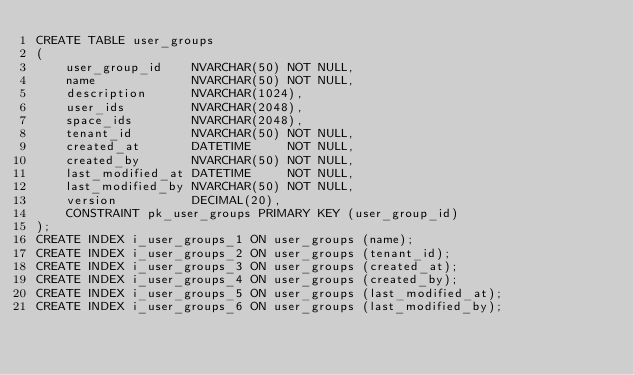<code> <loc_0><loc_0><loc_500><loc_500><_SQL_>CREATE TABLE user_groups
(
    user_group_id    NVARCHAR(50) NOT NULL,
    name             NVARCHAR(50) NOT NULL,
    description      NVARCHAR(1024),
    user_ids         NVARCHAR(2048),
    space_ids        NVARCHAR(2048),
    tenant_id        NVARCHAR(50) NOT NULL,
    created_at       DATETIME     NOT NULL,
    created_by       NVARCHAR(50) NOT NULL,
    last_modified_at DATETIME     NOT NULL,
    last_modified_by NVARCHAR(50) NOT NULL,
    version          DECIMAL(20),
    CONSTRAINT pk_user_groups PRIMARY KEY (user_group_id)
);
CREATE INDEX i_user_groups_1 ON user_groups (name);
CREATE INDEX i_user_groups_2 ON user_groups (tenant_id);
CREATE INDEX i_user_groups_3 ON user_groups (created_at);
CREATE INDEX i_user_groups_4 ON user_groups (created_by);
CREATE INDEX i_user_groups_5 ON user_groups (last_modified_at);
CREATE INDEX i_user_groups_6 ON user_groups (last_modified_by);
</code> 